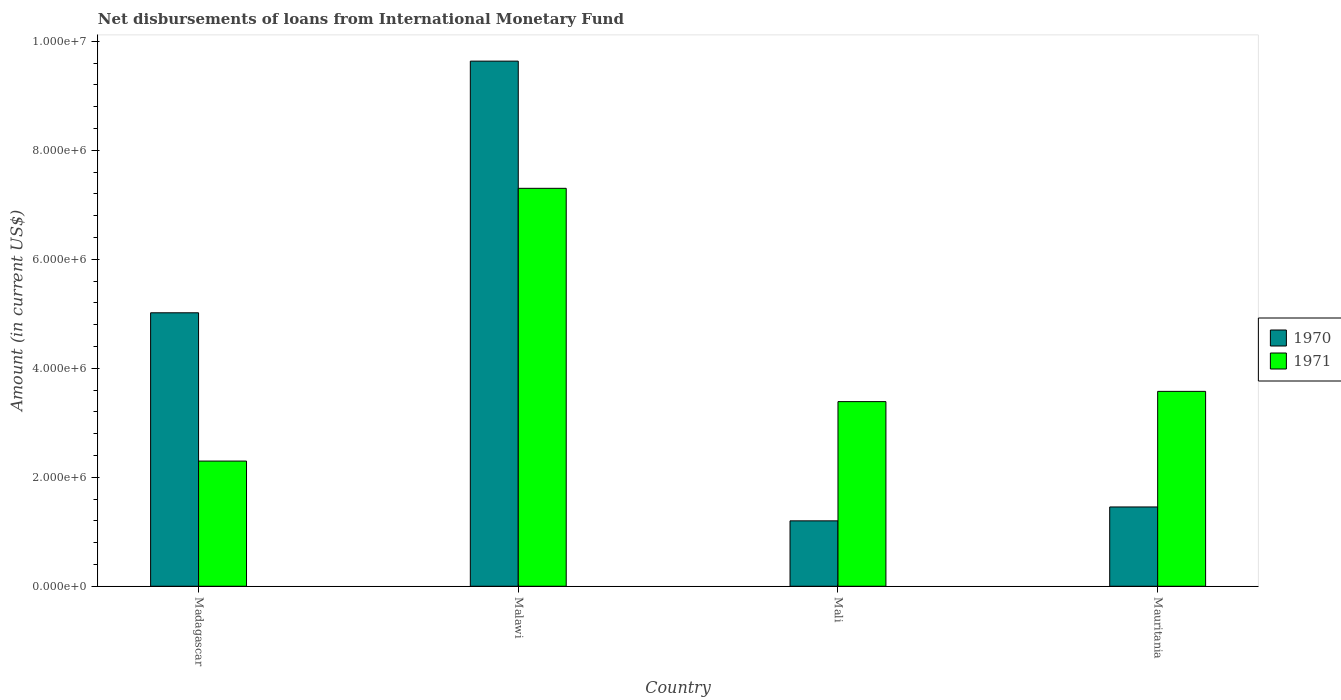How many groups of bars are there?
Keep it short and to the point. 4. Are the number of bars on each tick of the X-axis equal?
Offer a terse response. Yes. What is the label of the 2nd group of bars from the left?
Keep it short and to the point. Malawi. What is the amount of loans disbursed in 1971 in Malawi?
Make the answer very short. 7.30e+06. Across all countries, what is the maximum amount of loans disbursed in 1970?
Offer a terse response. 9.64e+06. Across all countries, what is the minimum amount of loans disbursed in 1971?
Provide a succinct answer. 2.30e+06. In which country was the amount of loans disbursed in 1970 maximum?
Make the answer very short. Malawi. In which country was the amount of loans disbursed in 1971 minimum?
Make the answer very short. Madagascar. What is the total amount of loans disbursed in 1971 in the graph?
Ensure brevity in your answer.  1.66e+07. What is the difference between the amount of loans disbursed in 1971 in Madagascar and that in Mali?
Ensure brevity in your answer.  -1.09e+06. What is the difference between the amount of loans disbursed in 1971 in Mali and the amount of loans disbursed in 1970 in Madagascar?
Offer a terse response. -1.63e+06. What is the average amount of loans disbursed in 1971 per country?
Ensure brevity in your answer.  4.14e+06. What is the difference between the amount of loans disbursed of/in 1970 and amount of loans disbursed of/in 1971 in Mauritania?
Provide a short and direct response. -2.12e+06. In how many countries, is the amount of loans disbursed in 1970 greater than 6400000 US$?
Keep it short and to the point. 1. What is the ratio of the amount of loans disbursed in 1971 in Malawi to that in Mauritania?
Offer a very short reply. 2.04. Is the difference between the amount of loans disbursed in 1970 in Madagascar and Malawi greater than the difference between the amount of loans disbursed in 1971 in Madagascar and Malawi?
Provide a short and direct response. Yes. What is the difference between the highest and the second highest amount of loans disbursed in 1970?
Offer a very short reply. 4.62e+06. What is the difference between the highest and the lowest amount of loans disbursed in 1971?
Give a very brief answer. 5.00e+06. In how many countries, is the amount of loans disbursed in 1971 greater than the average amount of loans disbursed in 1971 taken over all countries?
Your answer should be very brief. 1. Is the sum of the amount of loans disbursed in 1970 in Madagascar and Malawi greater than the maximum amount of loans disbursed in 1971 across all countries?
Make the answer very short. Yes. How many bars are there?
Make the answer very short. 8. Are all the bars in the graph horizontal?
Ensure brevity in your answer.  No. What is the difference between two consecutive major ticks on the Y-axis?
Your response must be concise. 2.00e+06. Are the values on the major ticks of Y-axis written in scientific E-notation?
Your answer should be very brief. Yes. Does the graph contain any zero values?
Provide a succinct answer. No. Does the graph contain grids?
Provide a succinct answer. No. Where does the legend appear in the graph?
Your response must be concise. Center right. How many legend labels are there?
Your answer should be compact. 2. What is the title of the graph?
Offer a terse response. Net disbursements of loans from International Monetary Fund. Does "1973" appear as one of the legend labels in the graph?
Your answer should be compact. No. What is the Amount (in current US$) of 1970 in Madagascar?
Your answer should be compact. 5.02e+06. What is the Amount (in current US$) of 1971 in Madagascar?
Give a very brief answer. 2.30e+06. What is the Amount (in current US$) in 1970 in Malawi?
Keep it short and to the point. 9.64e+06. What is the Amount (in current US$) in 1971 in Malawi?
Make the answer very short. 7.30e+06. What is the Amount (in current US$) of 1970 in Mali?
Keep it short and to the point. 1.20e+06. What is the Amount (in current US$) of 1971 in Mali?
Offer a terse response. 3.39e+06. What is the Amount (in current US$) in 1970 in Mauritania?
Provide a succinct answer. 1.46e+06. What is the Amount (in current US$) of 1971 in Mauritania?
Your answer should be compact. 3.58e+06. Across all countries, what is the maximum Amount (in current US$) in 1970?
Keep it short and to the point. 9.64e+06. Across all countries, what is the maximum Amount (in current US$) of 1971?
Provide a short and direct response. 7.30e+06. Across all countries, what is the minimum Amount (in current US$) of 1970?
Your answer should be compact. 1.20e+06. Across all countries, what is the minimum Amount (in current US$) of 1971?
Provide a succinct answer. 2.30e+06. What is the total Amount (in current US$) in 1970 in the graph?
Your answer should be very brief. 1.73e+07. What is the total Amount (in current US$) of 1971 in the graph?
Keep it short and to the point. 1.66e+07. What is the difference between the Amount (in current US$) in 1970 in Madagascar and that in Malawi?
Your answer should be compact. -4.62e+06. What is the difference between the Amount (in current US$) in 1971 in Madagascar and that in Malawi?
Your answer should be compact. -5.00e+06. What is the difference between the Amount (in current US$) of 1970 in Madagascar and that in Mali?
Offer a terse response. 3.82e+06. What is the difference between the Amount (in current US$) of 1971 in Madagascar and that in Mali?
Your response must be concise. -1.09e+06. What is the difference between the Amount (in current US$) in 1970 in Madagascar and that in Mauritania?
Offer a very short reply. 3.56e+06. What is the difference between the Amount (in current US$) in 1971 in Madagascar and that in Mauritania?
Offer a very short reply. -1.28e+06. What is the difference between the Amount (in current US$) of 1970 in Malawi and that in Mali?
Provide a succinct answer. 8.44e+06. What is the difference between the Amount (in current US$) of 1971 in Malawi and that in Mali?
Give a very brief answer. 3.91e+06. What is the difference between the Amount (in current US$) of 1970 in Malawi and that in Mauritania?
Make the answer very short. 8.18e+06. What is the difference between the Amount (in current US$) of 1971 in Malawi and that in Mauritania?
Ensure brevity in your answer.  3.73e+06. What is the difference between the Amount (in current US$) of 1970 in Mali and that in Mauritania?
Provide a succinct answer. -2.55e+05. What is the difference between the Amount (in current US$) in 1971 in Mali and that in Mauritania?
Offer a very short reply. -1.88e+05. What is the difference between the Amount (in current US$) in 1970 in Madagascar and the Amount (in current US$) in 1971 in Malawi?
Make the answer very short. -2.28e+06. What is the difference between the Amount (in current US$) of 1970 in Madagascar and the Amount (in current US$) of 1971 in Mali?
Your response must be concise. 1.63e+06. What is the difference between the Amount (in current US$) in 1970 in Madagascar and the Amount (in current US$) in 1971 in Mauritania?
Your answer should be very brief. 1.44e+06. What is the difference between the Amount (in current US$) of 1970 in Malawi and the Amount (in current US$) of 1971 in Mali?
Make the answer very short. 6.25e+06. What is the difference between the Amount (in current US$) in 1970 in Malawi and the Amount (in current US$) in 1971 in Mauritania?
Ensure brevity in your answer.  6.06e+06. What is the difference between the Amount (in current US$) of 1970 in Mali and the Amount (in current US$) of 1971 in Mauritania?
Make the answer very short. -2.38e+06. What is the average Amount (in current US$) of 1970 per country?
Offer a terse response. 4.33e+06. What is the average Amount (in current US$) of 1971 per country?
Give a very brief answer. 4.14e+06. What is the difference between the Amount (in current US$) in 1970 and Amount (in current US$) in 1971 in Madagascar?
Ensure brevity in your answer.  2.72e+06. What is the difference between the Amount (in current US$) in 1970 and Amount (in current US$) in 1971 in Malawi?
Keep it short and to the point. 2.33e+06. What is the difference between the Amount (in current US$) in 1970 and Amount (in current US$) in 1971 in Mali?
Offer a terse response. -2.19e+06. What is the difference between the Amount (in current US$) in 1970 and Amount (in current US$) in 1971 in Mauritania?
Make the answer very short. -2.12e+06. What is the ratio of the Amount (in current US$) in 1970 in Madagascar to that in Malawi?
Your answer should be very brief. 0.52. What is the ratio of the Amount (in current US$) in 1971 in Madagascar to that in Malawi?
Your answer should be compact. 0.31. What is the ratio of the Amount (in current US$) of 1970 in Madagascar to that in Mali?
Give a very brief answer. 4.18. What is the ratio of the Amount (in current US$) of 1971 in Madagascar to that in Mali?
Give a very brief answer. 0.68. What is the ratio of the Amount (in current US$) in 1970 in Madagascar to that in Mauritania?
Offer a very short reply. 3.45. What is the ratio of the Amount (in current US$) of 1971 in Madagascar to that in Mauritania?
Your response must be concise. 0.64. What is the ratio of the Amount (in current US$) of 1970 in Malawi to that in Mali?
Your answer should be very brief. 8.03. What is the ratio of the Amount (in current US$) in 1971 in Malawi to that in Mali?
Make the answer very short. 2.16. What is the ratio of the Amount (in current US$) in 1970 in Malawi to that in Mauritania?
Ensure brevity in your answer.  6.62. What is the ratio of the Amount (in current US$) in 1971 in Malawi to that in Mauritania?
Your answer should be very brief. 2.04. What is the ratio of the Amount (in current US$) in 1970 in Mali to that in Mauritania?
Keep it short and to the point. 0.82. What is the difference between the highest and the second highest Amount (in current US$) in 1970?
Ensure brevity in your answer.  4.62e+06. What is the difference between the highest and the second highest Amount (in current US$) of 1971?
Provide a short and direct response. 3.73e+06. What is the difference between the highest and the lowest Amount (in current US$) of 1970?
Make the answer very short. 8.44e+06. What is the difference between the highest and the lowest Amount (in current US$) of 1971?
Offer a terse response. 5.00e+06. 